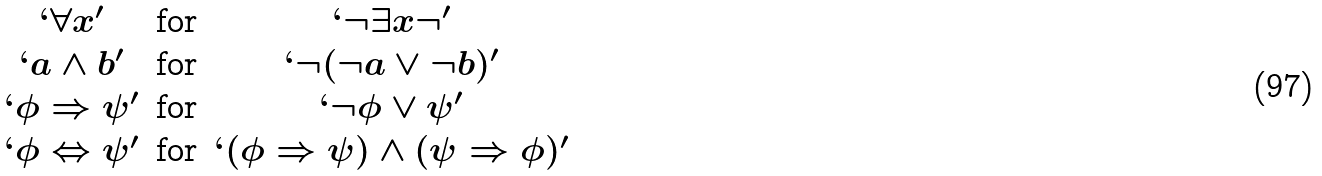Convert formula to latex. <formula><loc_0><loc_0><loc_500><loc_500>\begin{matrix} ` \forall x \rq & \text {for} & ` \neg \exists x \neg \rq \\ ` a \wedge b \rq & \text {for} & ` \neg ( \neg a \vee \neg b ) \rq \\ ` \phi \Rightarrow \psi \rq & \text {for} & ` \neg \phi \vee \psi \rq \\ ` \phi \Leftrightarrow \psi \rq & \text {for} & ` ( \phi \Rightarrow \psi ) \wedge ( \psi \Rightarrow \phi ) \rq \\ \end{matrix}</formula> 